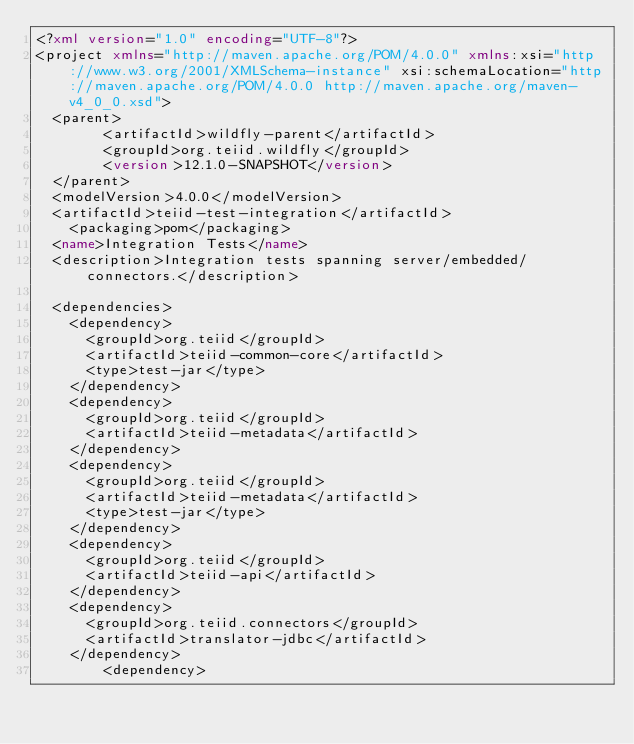Convert code to text. <code><loc_0><loc_0><loc_500><loc_500><_XML_><?xml version="1.0" encoding="UTF-8"?>
<project xmlns="http://maven.apache.org/POM/4.0.0" xmlns:xsi="http://www.w3.org/2001/XMLSchema-instance" xsi:schemaLocation="http://maven.apache.org/POM/4.0.0 http://maven.apache.org/maven-v4_0_0.xsd">
	<parent>
        <artifactId>wildfly-parent</artifactId>
        <groupId>org.teiid.wildfly</groupId>
        <version>12.1.0-SNAPSHOT</version>
	</parent>
	<modelVersion>4.0.0</modelVersion>
	<artifactId>teiid-test-integration</artifactId>
  	<packaging>pom</packaging>
	<name>Integration Tests</name>
	<description>Integration tests spanning	server/embedded/connectors.</description>

	<dependencies>
		<dependency>
			<groupId>org.teiid</groupId>
			<artifactId>teiid-common-core</artifactId>
			<type>test-jar</type>
		</dependency>
		<dependency>
			<groupId>org.teiid</groupId>
			<artifactId>teiid-metadata</artifactId>
		</dependency>
		<dependency>
			<groupId>org.teiid</groupId>
			<artifactId>teiid-metadata</artifactId>
			<type>test-jar</type>
		</dependency>
		<dependency>
			<groupId>org.teiid</groupId>
			<artifactId>teiid-api</artifactId>
		</dependency>
		<dependency>
			<groupId>org.teiid.connectors</groupId>
			<artifactId>translator-jdbc</artifactId>
		</dependency>
        <dependency></code> 